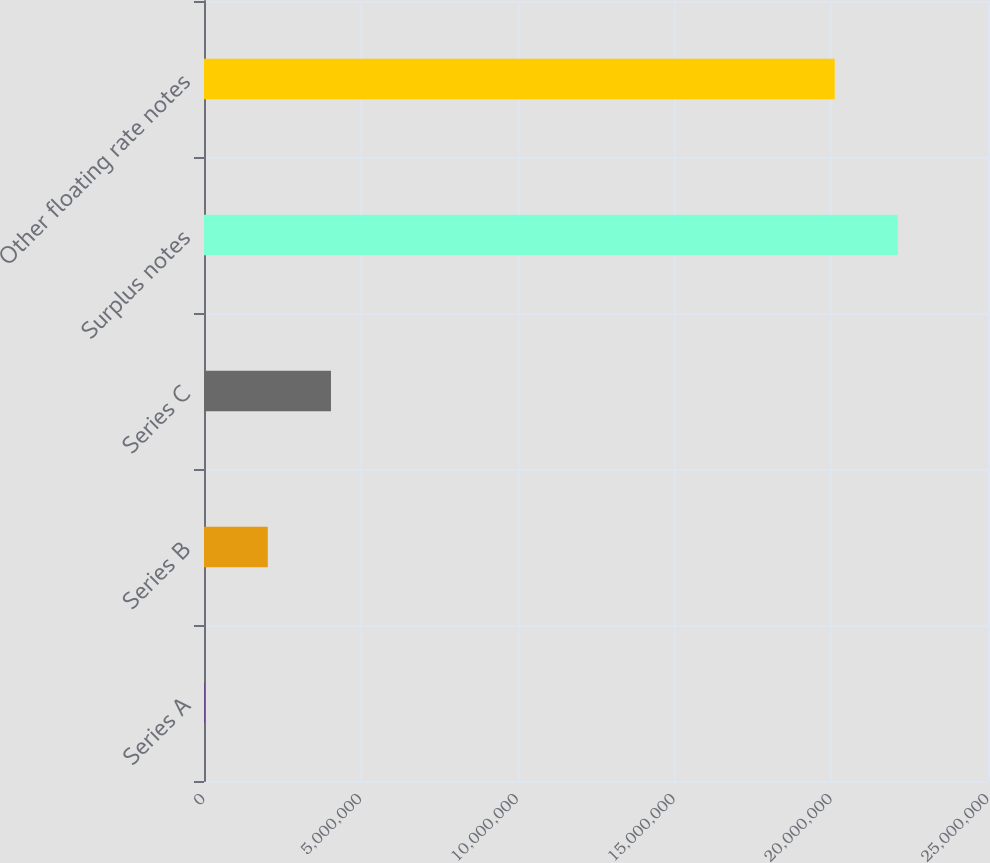Convert chart to OTSL. <chart><loc_0><loc_0><loc_500><loc_500><bar_chart><fcel>Series A<fcel>Series B<fcel>Series C<fcel>Surplus notes<fcel>Other floating rate notes<nl><fcel>20171<fcel>2.03436e+06<fcel>4.04855e+06<fcel>2.21262e+07<fcel>2.0112e+07<nl></chart> 